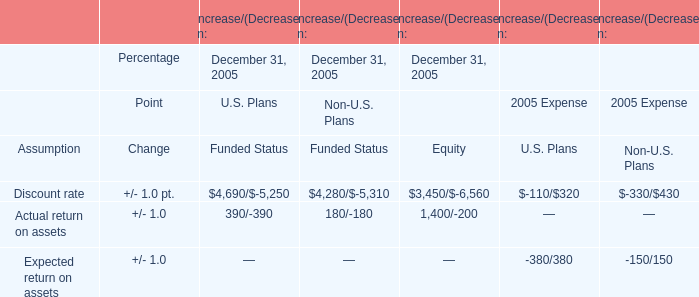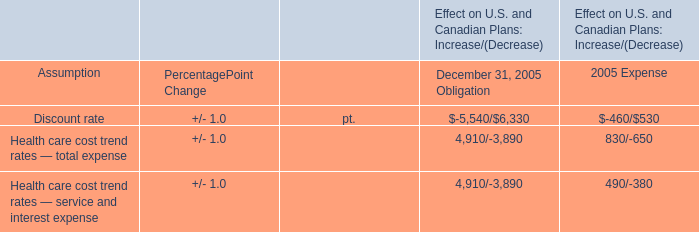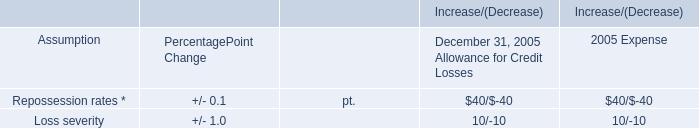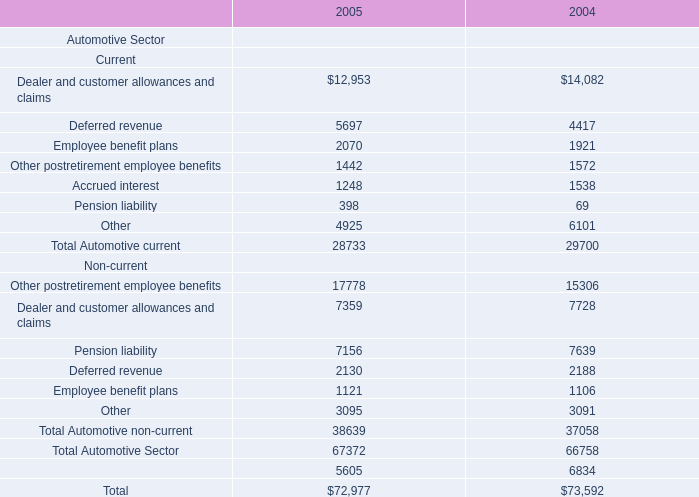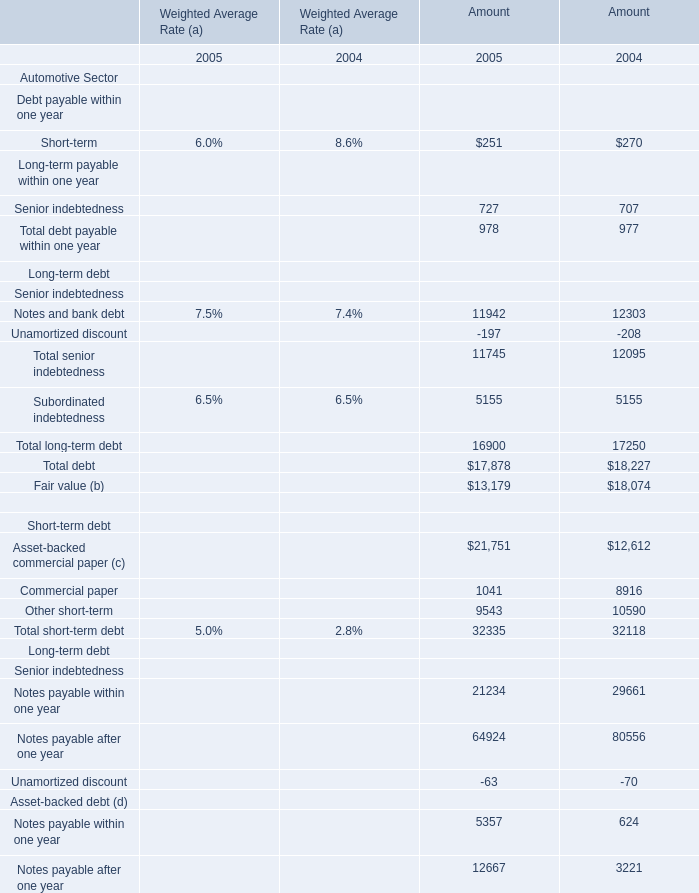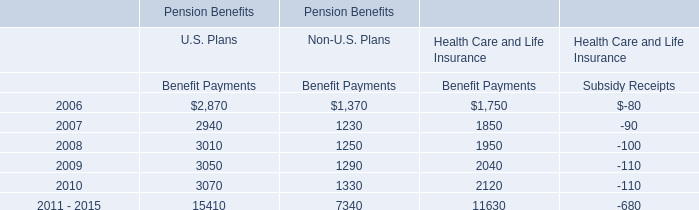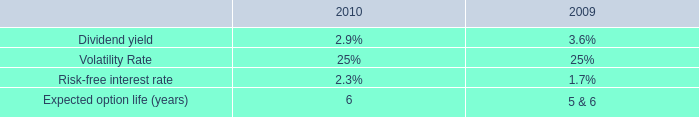what is the growth rate in the weighted-average grant date fair value of stock options from 2009 to 2010? 
Computations: ((11 - 7) / 7)
Answer: 0.57143. 